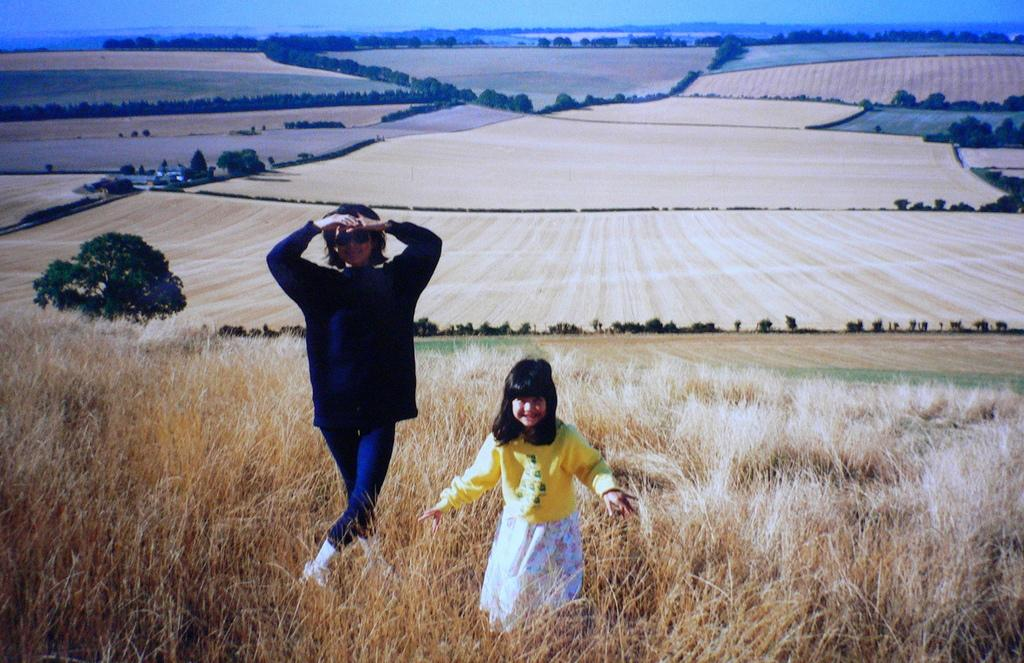Who is present in the image? There are girls in the image. Where are the girls located in the image? The girls are on the left side of the image. What type of environment is depicted in the image? There is greenery and fields in the image. Where is the nest located in the image? There is no nest present in the image. What type of juice is being consumed by the girls in the image? There is no juice visible in the image; only the girls and their surroundings are present. 